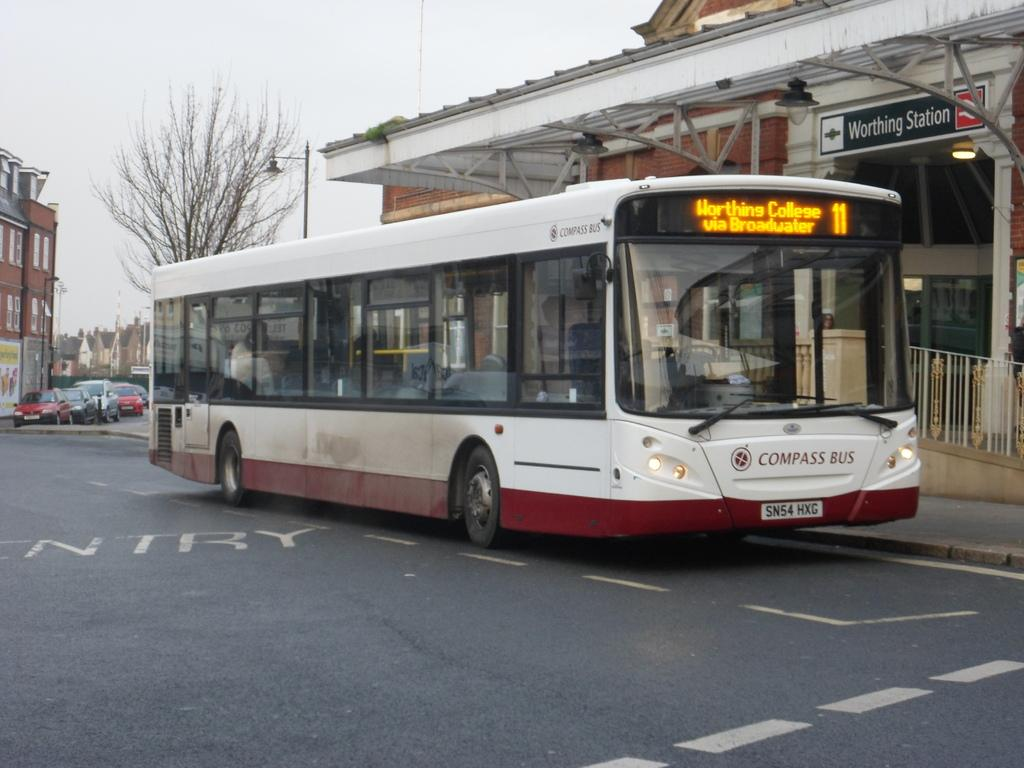Provide a one-sentence caption for the provided image. A Compass Bus is sitting at the Worthing Station. 